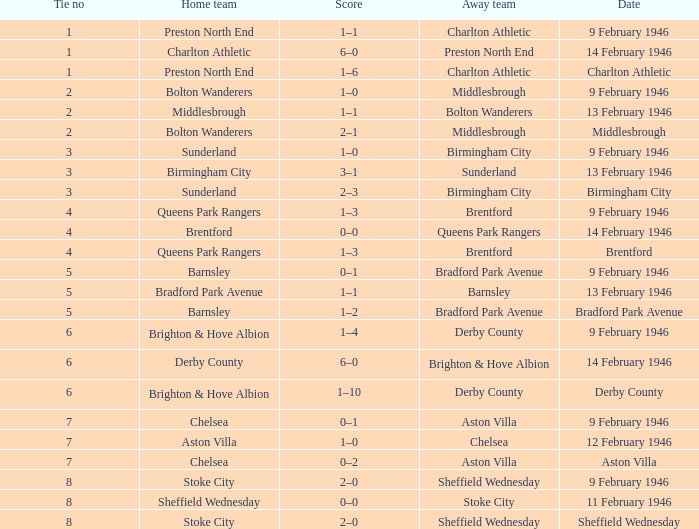Parse the full table. {'header': ['Tie no', 'Home team', 'Score', 'Away team', 'Date'], 'rows': [['1', 'Preston North End', '1–1', 'Charlton Athletic', '9 February 1946'], ['1', 'Charlton Athletic', '6–0', 'Preston North End', '14 February 1946'], ['1', 'Preston North End', '1–6', 'Charlton Athletic', 'Charlton Athletic'], ['2', 'Bolton Wanderers', '1–0', 'Middlesbrough', '9 February 1946'], ['2', 'Middlesbrough', '1–1', 'Bolton Wanderers', '13 February 1946'], ['2', 'Bolton Wanderers', '2–1', 'Middlesbrough', 'Middlesbrough'], ['3', 'Sunderland', '1–0', 'Birmingham City', '9 February 1946'], ['3', 'Birmingham City', '3–1', 'Sunderland', '13 February 1946'], ['3', 'Sunderland', '2–3', 'Birmingham City', 'Birmingham City'], ['4', 'Queens Park Rangers', '1–3', 'Brentford', '9 February 1946'], ['4', 'Brentford', '0–0', 'Queens Park Rangers', '14 February 1946'], ['4', 'Queens Park Rangers', '1–3', 'Brentford', 'Brentford'], ['5', 'Barnsley', '0–1', 'Bradford Park Avenue', '9 February 1946'], ['5', 'Bradford Park Avenue', '1–1', 'Barnsley', '13 February 1946'], ['5', 'Barnsley', '1–2', 'Bradford Park Avenue', 'Bradford Park Avenue'], ['6', 'Brighton & Hove Albion', '1–4', 'Derby County', '9 February 1946'], ['6', 'Derby County', '6–0', 'Brighton & Hove Albion', '14 February 1946'], ['6', 'Brighton & Hove Albion', '1–10', 'Derby County', 'Derby County'], ['7', 'Chelsea', '0–1', 'Aston Villa', '9 February 1946'], ['7', 'Aston Villa', '1–0', 'Chelsea', '12 February 1946'], ['7', 'Chelsea', '0–2', 'Aston Villa', 'Aston Villa'], ['8', 'Stoke City', '2–0', 'Sheffield Wednesday', '9 February 1946'], ['8', 'Sheffield Wednesday', '0–0', 'Stoke City', '11 February 1946'], ['8', 'Stoke City', '2–0', 'Sheffield Wednesday', 'Sheffield Wednesday']]} What is the average Tie no when the date is Birmingham City? 3.0. 